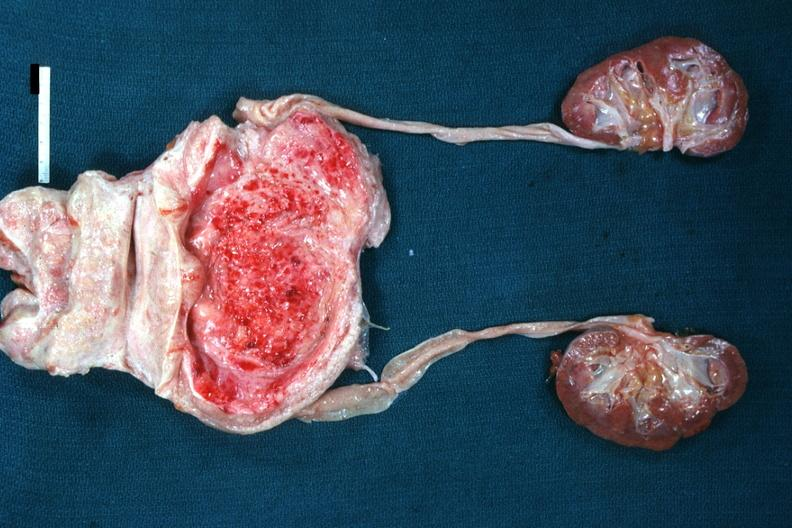what is present?
Answer the question using a single word or phrase. Hyperplasia 